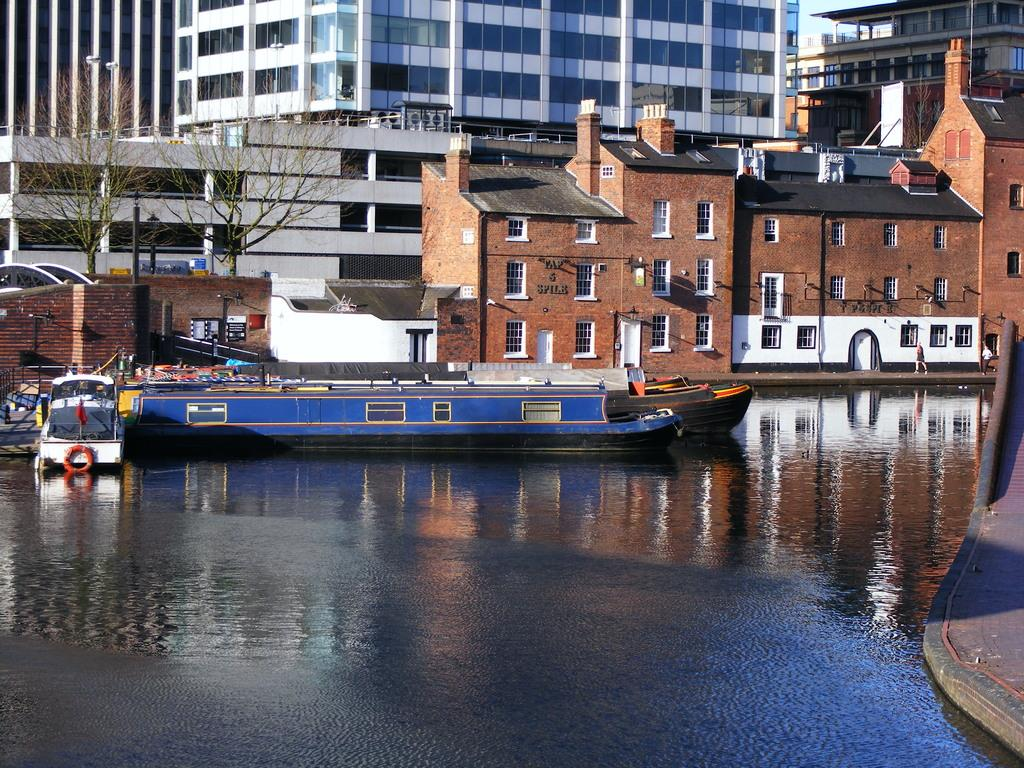What is the main subject of the image? The main subject of the image is a boat. Where is the boat located? The boat is in a canal. What can be seen in front of the boat? There are buildings and trees in front of the boat. How much sugar is in the boat in the image? There is no mention of sugar in the image, and it is not visible in the boat. 